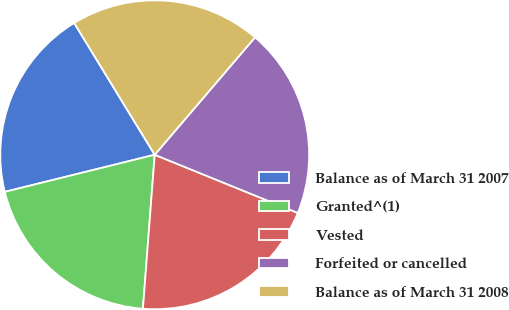Convert chart. <chart><loc_0><loc_0><loc_500><loc_500><pie_chart><fcel>Balance as of March 31 2007<fcel>Granted^(1)<fcel>Vested<fcel>Forfeited or cancelled<fcel>Balance as of March 31 2008<nl><fcel>20.13%<fcel>19.92%<fcel>20.07%<fcel>19.89%<fcel>19.98%<nl></chart> 